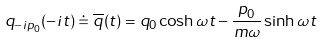<formula> <loc_0><loc_0><loc_500><loc_500>q _ { - i p _ { 0 } } ( - i t ) \doteq \overline { q } ( t ) = q _ { 0 } \cosh \omega t - { \frac { p _ { 0 } } { m \omega } } \sinh \omega t</formula> 